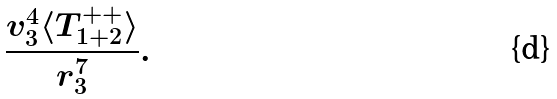<formula> <loc_0><loc_0><loc_500><loc_500>\frac { v _ { 3 } ^ { 4 } \langle T ^ { + + } _ { 1 + 2 } \rangle } { r _ { 3 } ^ { 7 } } .</formula> 